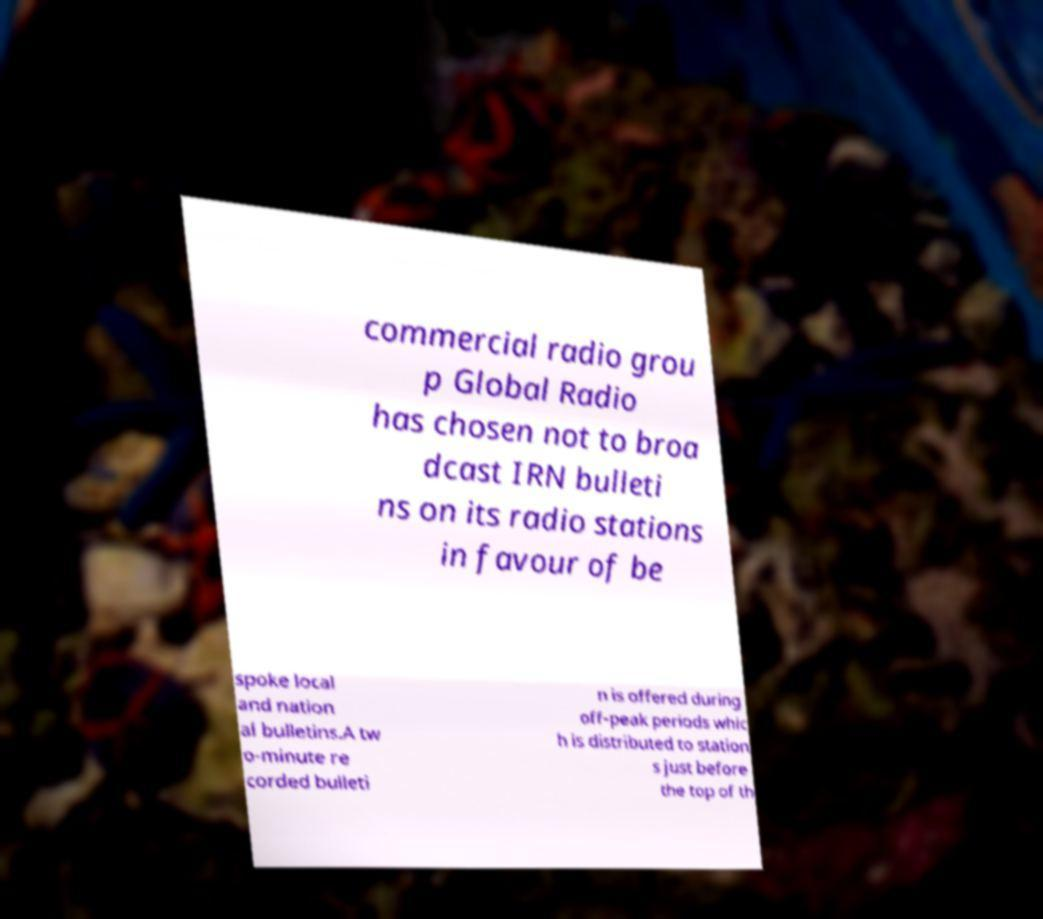Could you extract and type out the text from this image? commercial radio grou p Global Radio has chosen not to broa dcast IRN bulleti ns on its radio stations in favour of be spoke local and nation al bulletins.A tw o-minute re corded bulleti n is offered during off-peak periods whic h is distributed to station s just before the top of th 